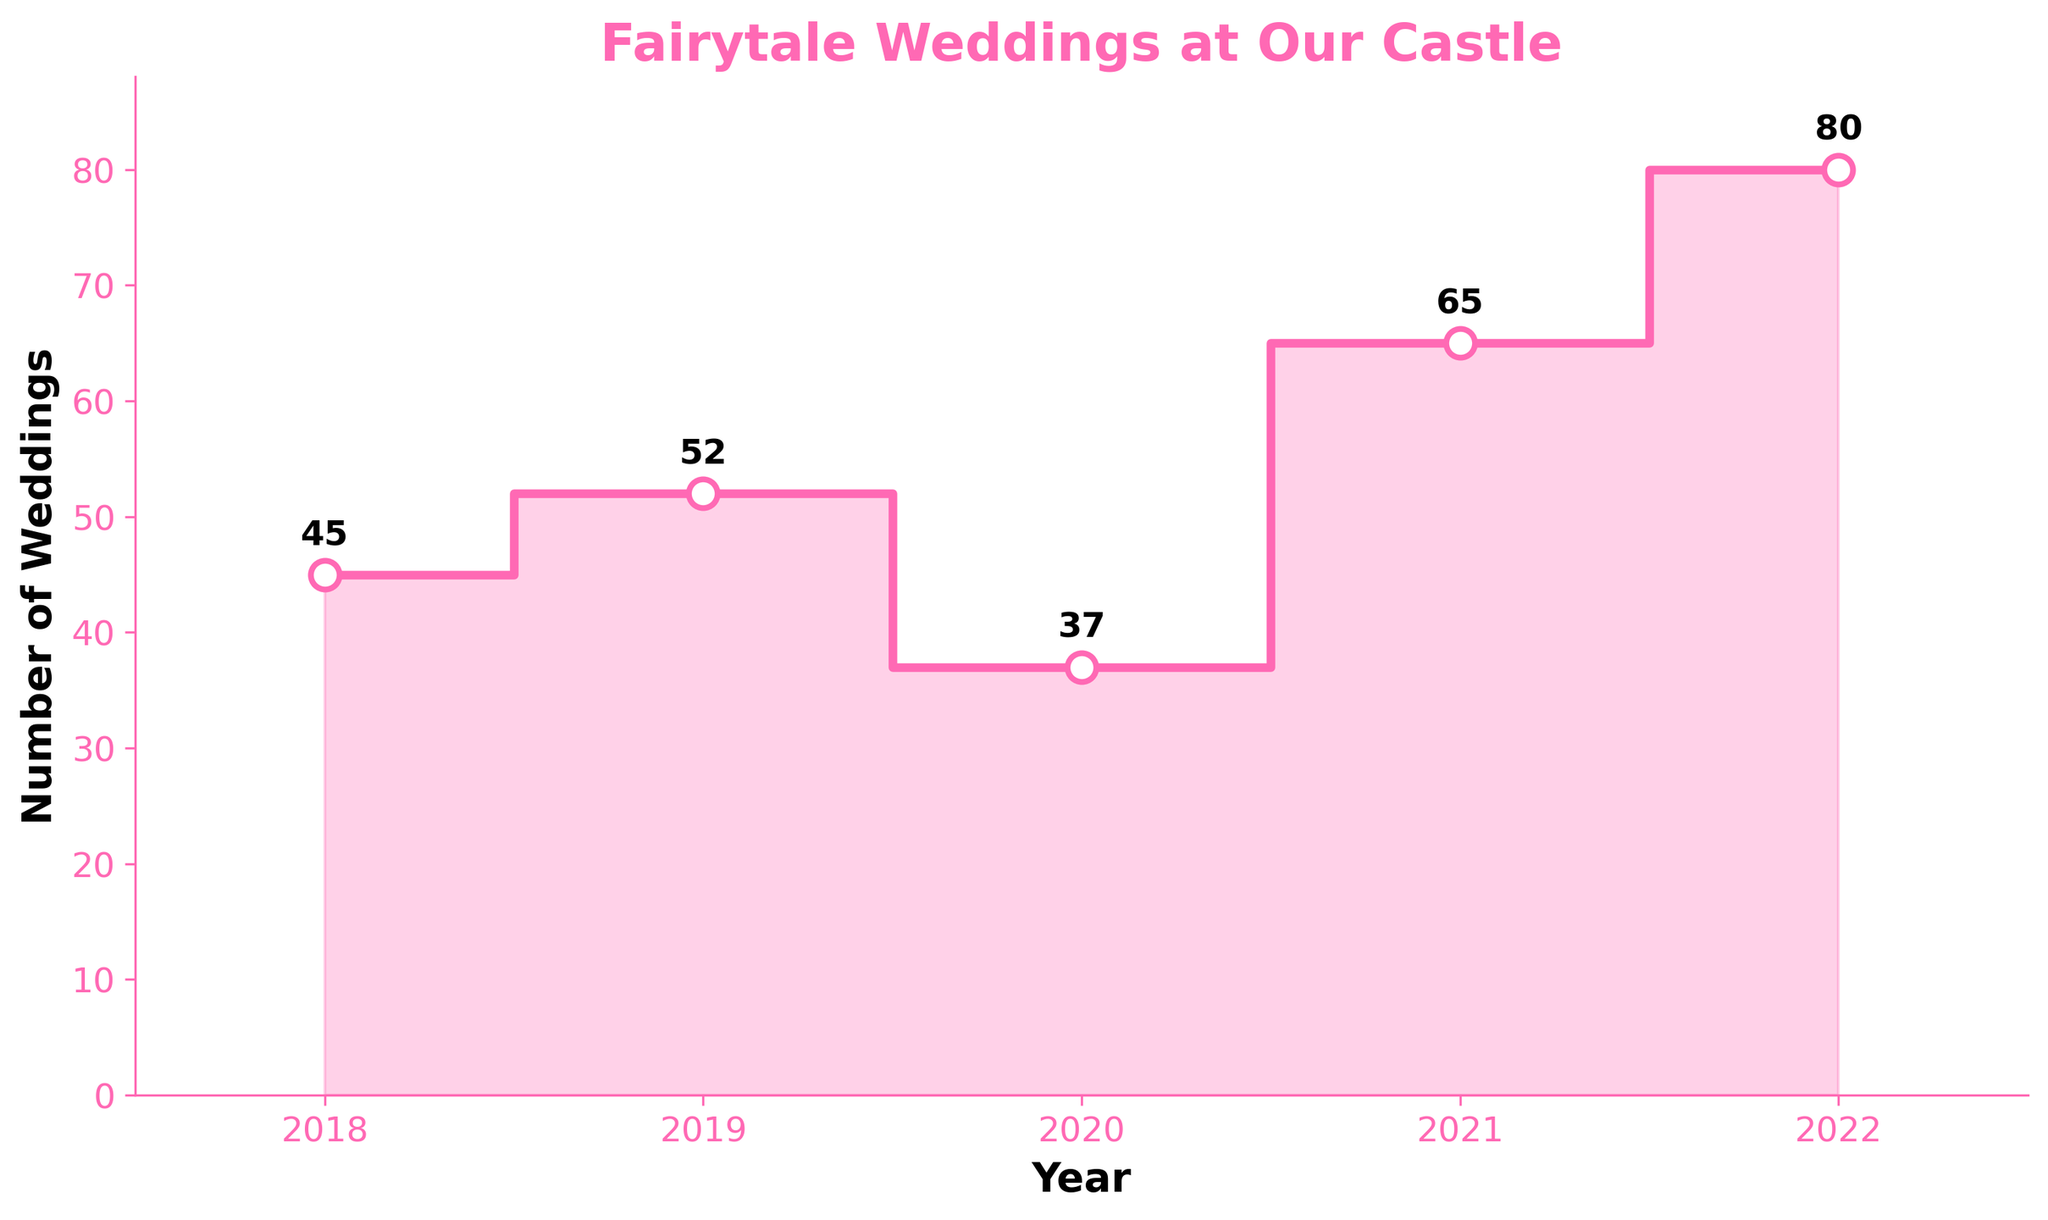What is the title of the plot? The title of the plot is usually located at the top of the figure and is used to describe what the data represents. In this case, it states "Fairytale Weddings at Our Castle".
Answer: Fairytale Weddings at Our Castle What does the y-axis represent? The y-axis usually represents the variable being measured. In this plot, it indicates the "Number of Weddings".
Answer: Number of Weddings In which year were the most weddings hosted? To find the year with the most weddings, look at the highest point on the y-axis corresponding to a specific year on the x-axis. The highest point is at 2022 with 80 weddings.
Answer: 2022 What is the trend in the number of weddings from 2018 to 2022? Observe the stepwise progression of the plot from left to right. The number of weddings increases overall from 2018 to 2022, with a dip in 2020.
Answer: Increasing How many weddings were hosted in 2019, and how does this compare to 2018? First, identify the number of weddings in 2019, which is 52. Then, compare it to the number in 2018, which is 45. The difference is 52 - 45 = 7, so there were 7 more weddings in 2019.
Answer: 52, 7 more What is the average number of weddings hosted per year from 2018 to 2022? Add the total number of weddings for each year (45 + 52 + 37 + 65 + 80 = 279) and divide by the number of years (5). The average is 279 / 5 = 55.8.
Answer: 55.8 Which year saw the biggest decrease in the number of weddings compared to the previous year? Identify the year-to-year changes: 2019(+7), 2020(-15), 2021(+28), 2022(+15). The biggest decrease is from 2019 to 2020, which is a drop of 15 weddings.
Answer: 2020 How many weddings were hosted in the year following the year with the fewest weddings? The fewest weddings were hosted in 2020, with 37 weddings. In the following year, 2021, there were 65 weddings.
Answer: 65 Estimate the percentage increase in the number of weddings from 2020 to 2021. Calculate the increase from 2020 to 2021 (65 - 37 = 28). Then, find the percentage: (28 / 37) * 100 ≈ 75.68%.
Answer: 75.68% What is the difference in the number of weddings between 2021 and 2022? Identify the number of weddings in 2021 (65) and 2022 (80). The difference is 80 - 65 = 15.
Answer: 15 